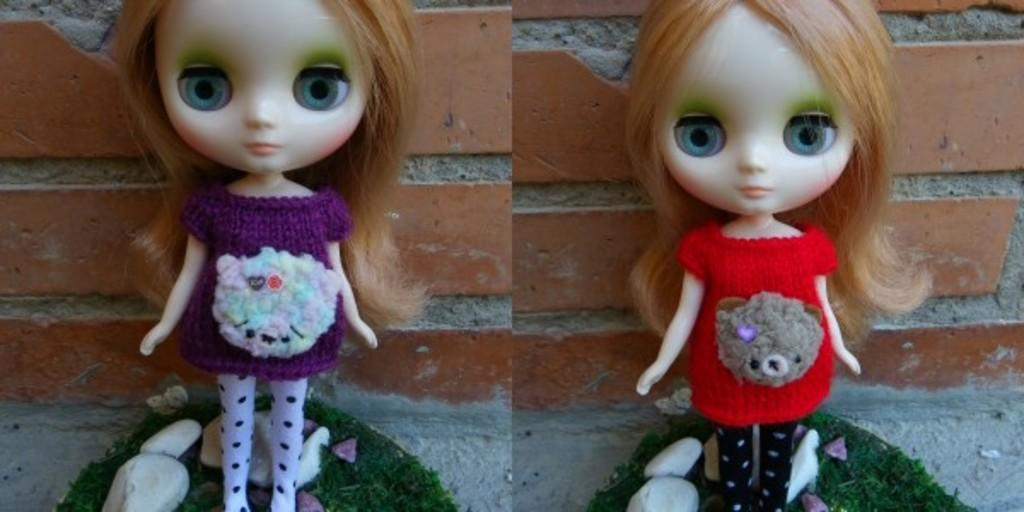What is present in the background of the image? There is a wall in the image. How many dolls can be seen in the image? There are two dolls in the image. Where are the dolls located in relation to the wall? The dolls are standing in front of the wall. Can you see any visible veins on the dolls in the image? There are no visible veins on the dolls in the image, as they are inanimate objects and do not have a circulatory system. What type of underwear are the dolls wearing in the image? Dolls do not wear underwear, as they are not real people and do not require clothing. 